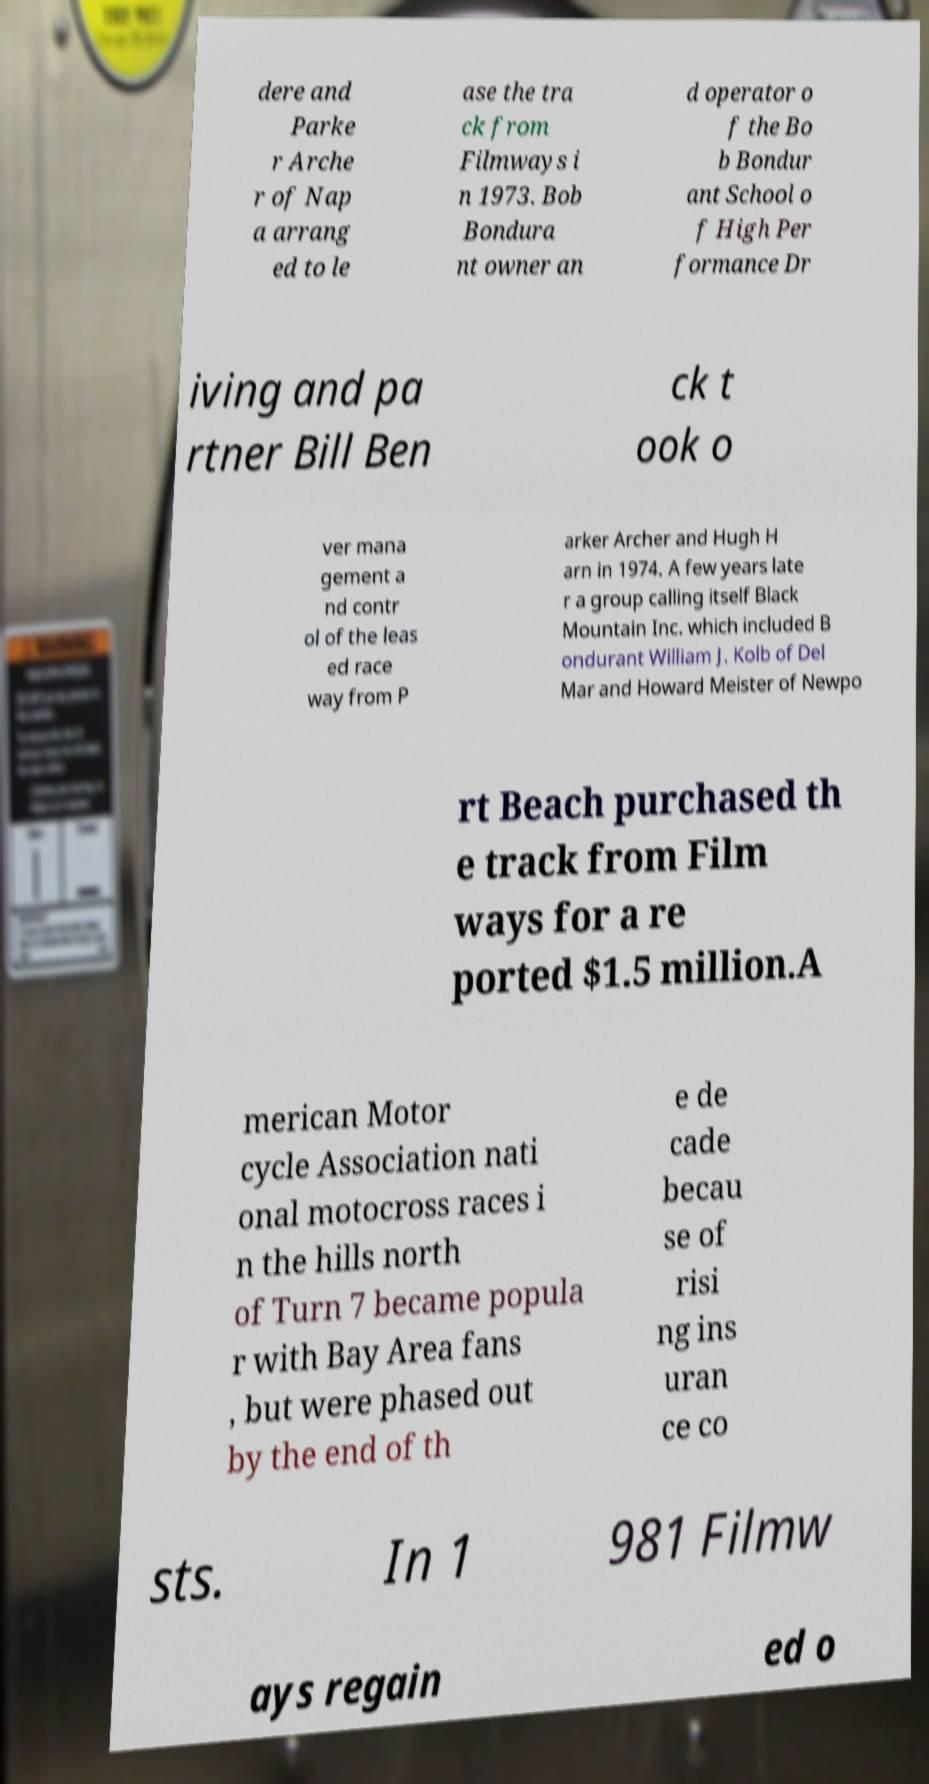Can you accurately transcribe the text from the provided image for me? dere and Parke r Arche r of Nap a arrang ed to le ase the tra ck from Filmways i n 1973. Bob Bondura nt owner an d operator o f the Bo b Bondur ant School o f High Per formance Dr iving and pa rtner Bill Ben ck t ook o ver mana gement a nd contr ol of the leas ed race way from P arker Archer and Hugh H arn in 1974. A few years late r a group calling itself Black Mountain Inc. which included B ondurant William J. Kolb of Del Mar and Howard Meister of Newpo rt Beach purchased th e track from Film ways for a re ported $1.5 million.A merican Motor cycle Association nati onal motocross races i n the hills north of Turn 7 became popula r with Bay Area fans , but were phased out by the end of th e de cade becau se of risi ng ins uran ce co sts. In 1 981 Filmw ays regain ed o 